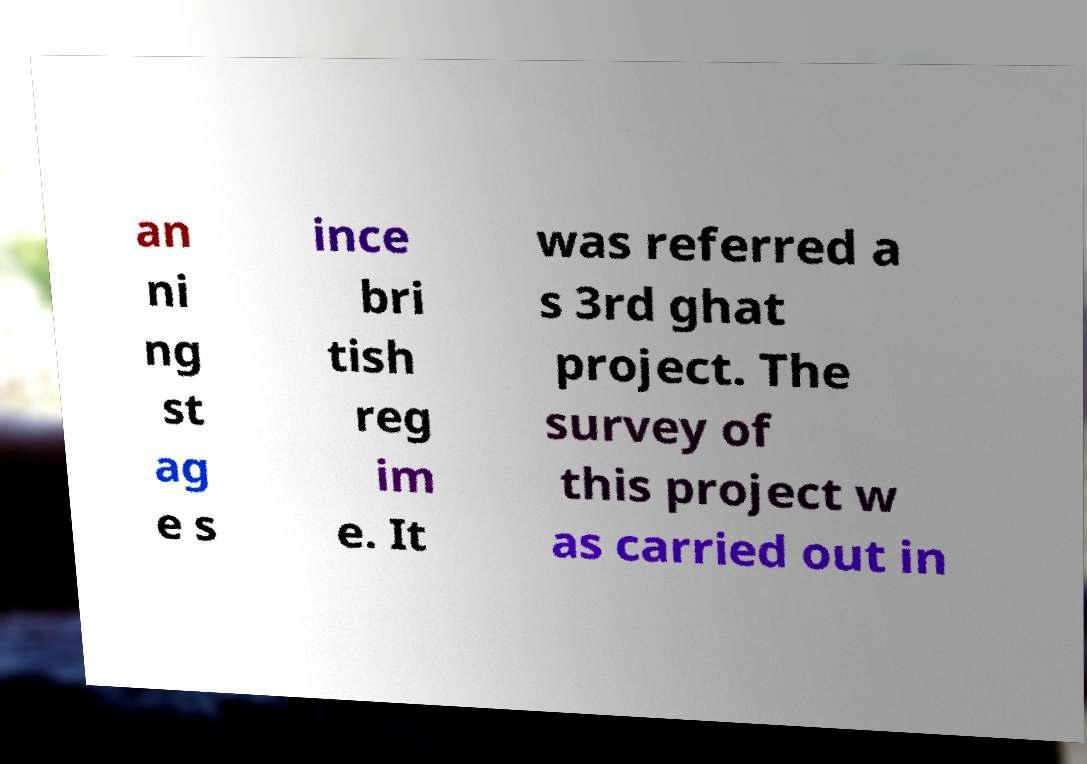Can you accurately transcribe the text from the provided image for me? an ni ng st ag e s ince bri tish reg im e. It was referred a s 3rd ghat project. The survey of this project w as carried out in 